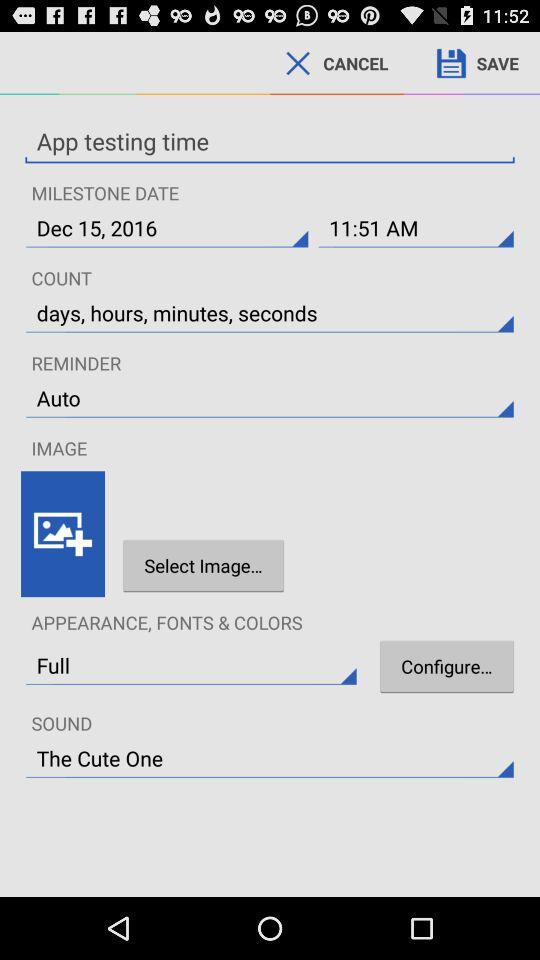What is the sound? The sound is "The Cute One". 